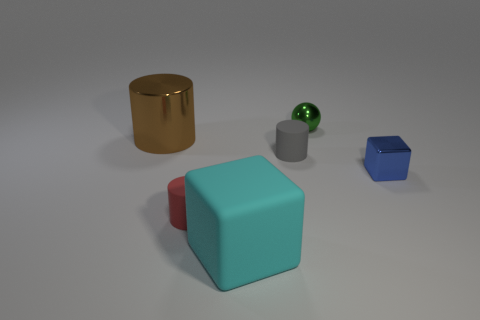What time of day does this scene portray? The image does not provide explicit information on the time of day, as there are no windows or natural light source indicators. The neutral background and even lighting suggest a controlled environment, possibly indicating an indoor setting where time of day is not discernible. 